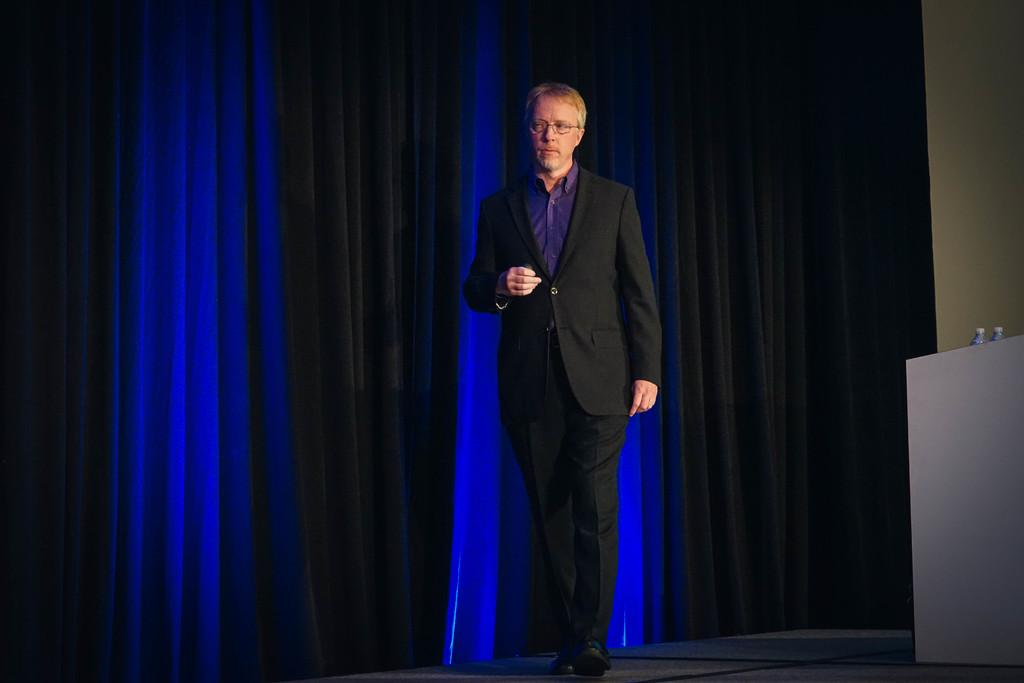Who is the main subject in the image? There is a man in the image. What is the man doing in the image? The man is standing on a dais. What accessory is the man wearing in the image? The man is wearing spectacles. What type of fabric is visible in the image? There are curtains visible in the image. What items can be seen on a table in the image? There are water bottles on a table in the image. What type of flower is the man holding in the image? There is no flower present in the image; the man is not holding anything. 